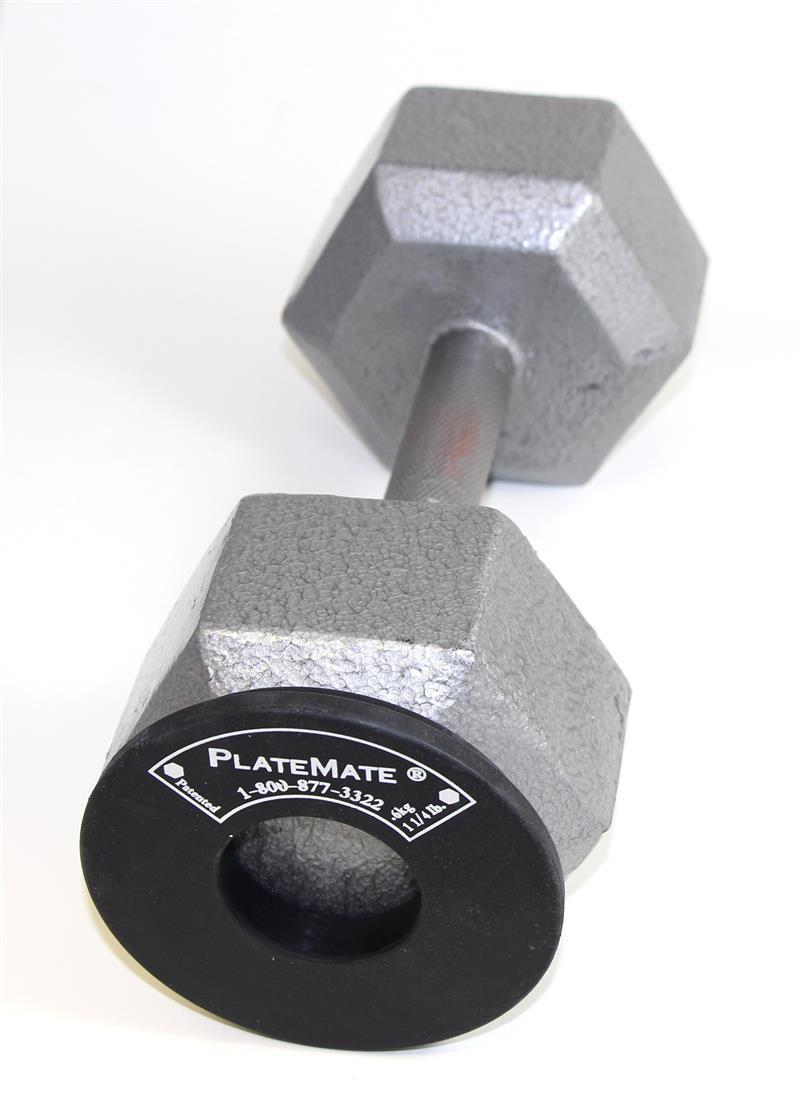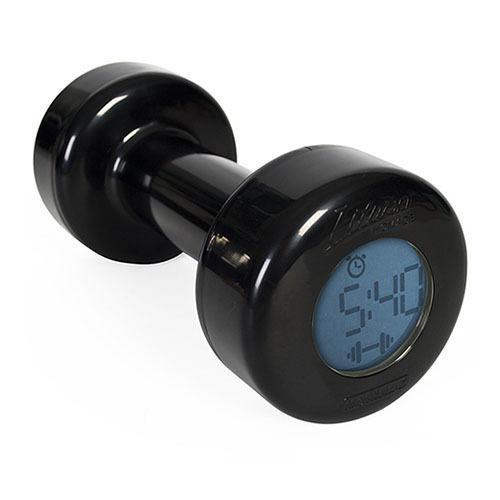The first image is the image on the left, the second image is the image on the right. Assess this claim about the two images: "AN image shows exactly one black dumbbell.". Correct or not? Answer yes or no. Yes. The first image is the image on the left, the second image is the image on the right. For the images shown, is this caption "There is one black free weight" true? Answer yes or no. Yes. 